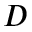Convert formula to latex. <formula><loc_0><loc_0><loc_500><loc_500>D</formula> 